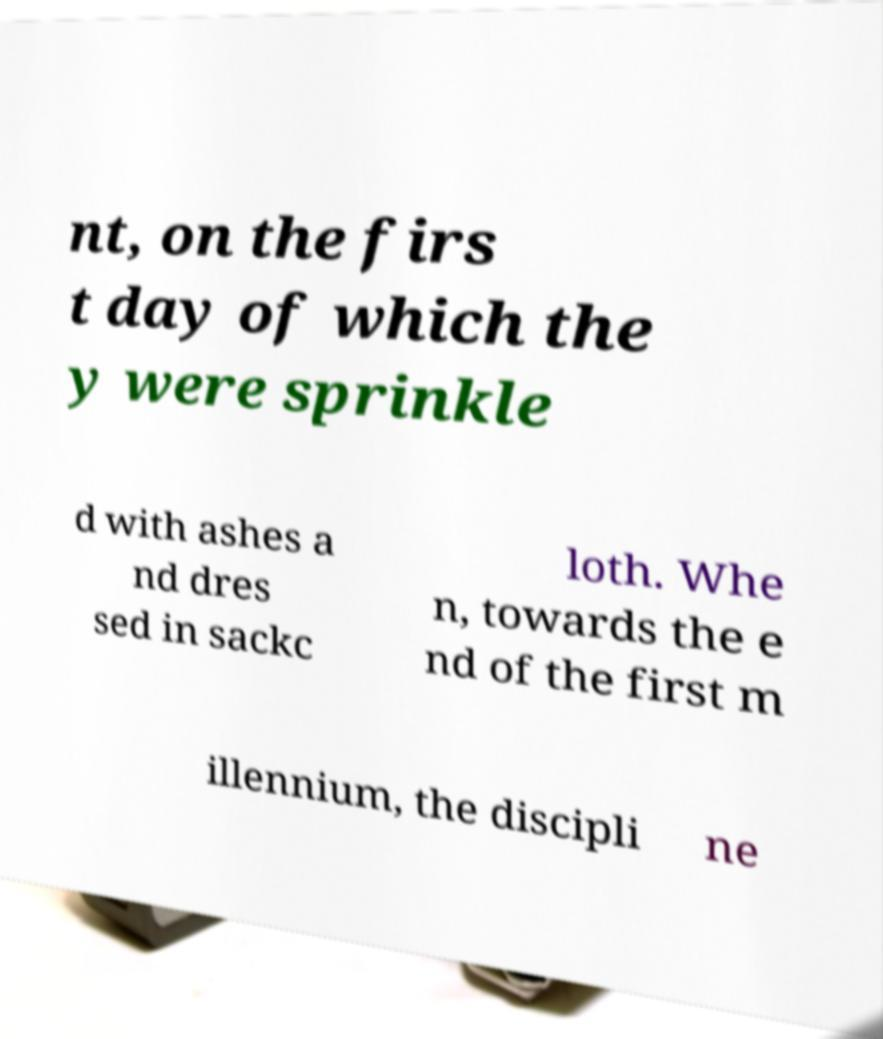I need the written content from this picture converted into text. Can you do that? nt, on the firs t day of which the y were sprinkle d with ashes a nd dres sed in sackc loth. Whe n, towards the e nd of the first m illennium, the discipli ne 